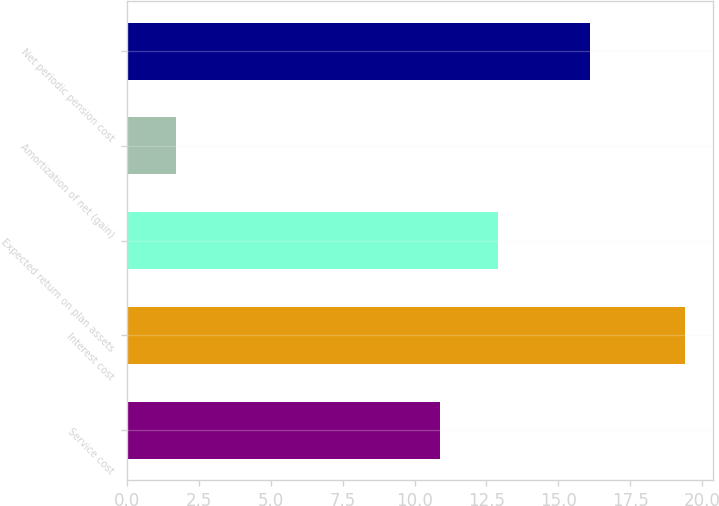Convert chart. <chart><loc_0><loc_0><loc_500><loc_500><bar_chart><fcel>Service cost<fcel>Interest cost<fcel>Expected return on plan assets<fcel>Amortization of net (gain)<fcel>Net periodic pension cost<nl><fcel>10.9<fcel>19.4<fcel>12.9<fcel>1.7<fcel>16.1<nl></chart> 